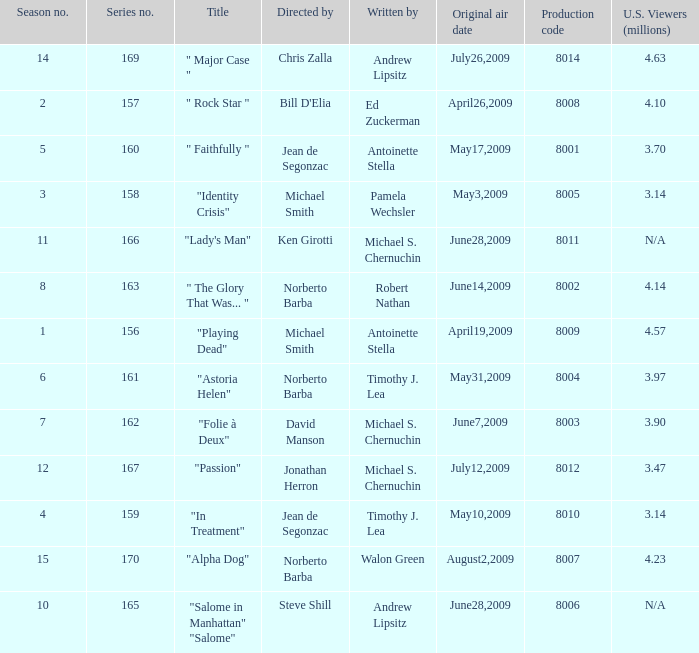How many writers write the episode whose director is Jonathan Herron? 1.0. 